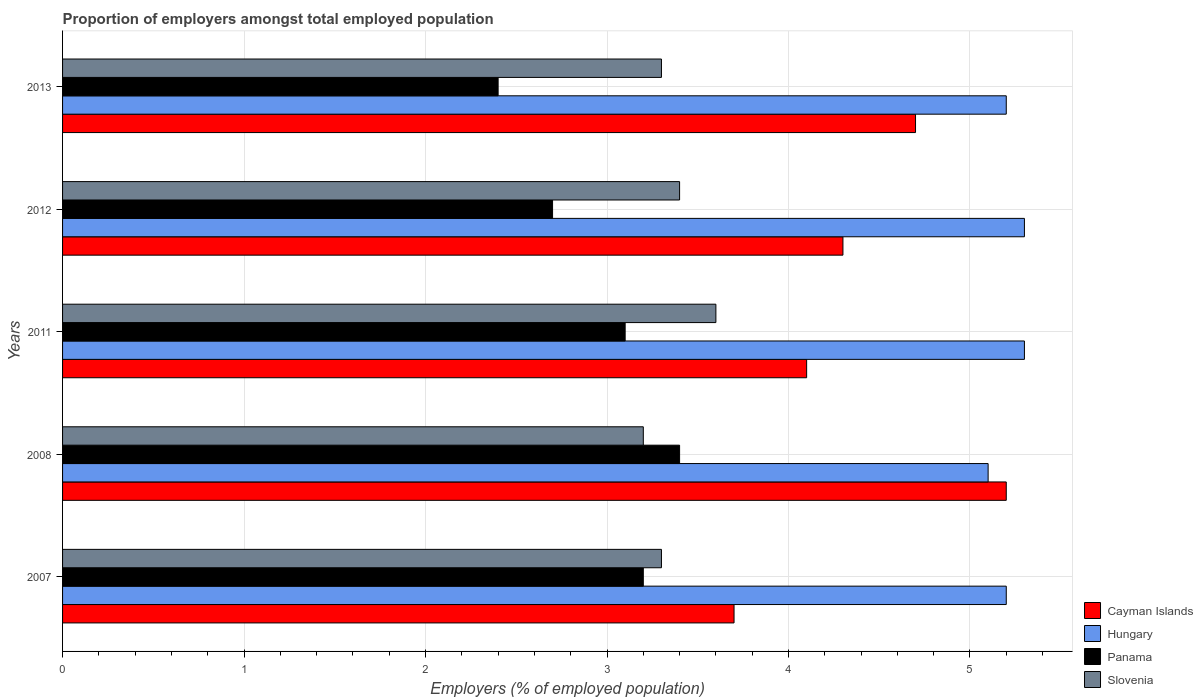How many groups of bars are there?
Your answer should be very brief. 5. Are the number of bars per tick equal to the number of legend labels?
Offer a very short reply. Yes. What is the proportion of employers in Slovenia in 2012?
Keep it short and to the point. 3.4. Across all years, what is the maximum proportion of employers in Cayman Islands?
Offer a terse response. 5.2. Across all years, what is the minimum proportion of employers in Slovenia?
Make the answer very short. 3.2. In which year was the proportion of employers in Hungary maximum?
Your answer should be very brief. 2011. What is the total proportion of employers in Panama in the graph?
Provide a short and direct response. 14.8. What is the difference between the proportion of employers in Hungary in 2008 and that in 2011?
Provide a succinct answer. -0.2. What is the difference between the proportion of employers in Panama in 2007 and the proportion of employers in Slovenia in 2013?
Ensure brevity in your answer.  -0.1. What is the average proportion of employers in Cayman Islands per year?
Provide a succinct answer. 4.4. In the year 2013, what is the difference between the proportion of employers in Slovenia and proportion of employers in Hungary?
Provide a succinct answer. -1.9. What is the ratio of the proportion of employers in Slovenia in 2007 to that in 2013?
Ensure brevity in your answer.  1. What is the difference between the highest and the lowest proportion of employers in Panama?
Keep it short and to the point. 1. What does the 2nd bar from the top in 2013 represents?
Ensure brevity in your answer.  Panama. What does the 3rd bar from the bottom in 2008 represents?
Your answer should be very brief. Panama. Is it the case that in every year, the sum of the proportion of employers in Hungary and proportion of employers in Panama is greater than the proportion of employers in Cayman Islands?
Provide a succinct answer. Yes. What is the difference between two consecutive major ticks on the X-axis?
Provide a short and direct response. 1. Does the graph contain any zero values?
Make the answer very short. No. What is the title of the graph?
Your response must be concise. Proportion of employers amongst total employed population. Does "Djibouti" appear as one of the legend labels in the graph?
Your answer should be compact. No. What is the label or title of the X-axis?
Give a very brief answer. Employers (% of employed population). What is the Employers (% of employed population) in Cayman Islands in 2007?
Give a very brief answer. 3.7. What is the Employers (% of employed population) of Hungary in 2007?
Your answer should be compact. 5.2. What is the Employers (% of employed population) in Panama in 2007?
Give a very brief answer. 3.2. What is the Employers (% of employed population) in Slovenia in 2007?
Your response must be concise. 3.3. What is the Employers (% of employed population) in Cayman Islands in 2008?
Ensure brevity in your answer.  5.2. What is the Employers (% of employed population) of Hungary in 2008?
Your answer should be very brief. 5.1. What is the Employers (% of employed population) of Panama in 2008?
Ensure brevity in your answer.  3.4. What is the Employers (% of employed population) of Slovenia in 2008?
Keep it short and to the point. 3.2. What is the Employers (% of employed population) of Cayman Islands in 2011?
Your response must be concise. 4.1. What is the Employers (% of employed population) in Hungary in 2011?
Offer a very short reply. 5.3. What is the Employers (% of employed population) of Panama in 2011?
Your response must be concise. 3.1. What is the Employers (% of employed population) of Slovenia in 2011?
Provide a short and direct response. 3.6. What is the Employers (% of employed population) in Cayman Islands in 2012?
Give a very brief answer. 4.3. What is the Employers (% of employed population) of Hungary in 2012?
Give a very brief answer. 5.3. What is the Employers (% of employed population) in Panama in 2012?
Keep it short and to the point. 2.7. What is the Employers (% of employed population) in Slovenia in 2012?
Your answer should be compact. 3.4. What is the Employers (% of employed population) of Cayman Islands in 2013?
Your answer should be very brief. 4.7. What is the Employers (% of employed population) of Hungary in 2013?
Ensure brevity in your answer.  5.2. What is the Employers (% of employed population) in Panama in 2013?
Make the answer very short. 2.4. What is the Employers (% of employed population) in Slovenia in 2013?
Provide a short and direct response. 3.3. Across all years, what is the maximum Employers (% of employed population) of Cayman Islands?
Give a very brief answer. 5.2. Across all years, what is the maximum Employers (% of employed population) in Hungary?
Give a very brief answer. 5.3. Across all years, what is the maximum Employers (% of employed population) of Panama?
Provide a succinct answer. 3.4. Across all years, what is the maximum Employers (% of employed population) of Slovenia?
Your answer should be compact. 3.6. Across all years, what is the minimum Employers (% of employed population) in Cayman Islands?
Provide a short and direct response. 3.7. Across all years, what is the minimum Employers (% of employed population) in Hungary?
Your answer should be very brief. 5.1. Across all years, what is the minimum Employers (% of employed population) in Panama?
Give a very brief answer. 2.4. Across all years, what is the minimum Employers (% of employed population) of Slovenia?
Keep it short and to the point. 3.2. What is the total Employers (% of employed population) in Cayman Islands in the graph?
Provide a succinct answer. 22. What is the total Employers (% of employed population) in Hungary in the graph?
Your answer should be very brief. 26.1. What is the total Employers (% of employed population) in Panama in the graph?
Give a very brief answer. 14.8. What is the total Employers (% of employed population) of Slovenia in the graph?
Offer a terse response. 16.8. What is the difference between the Employers (% of employed population) of Cayman Islands in 2007 and that in 2008?
Provide a short and direct response. -1.5. What is the difference between the Employers (% of employed population) of Panama in 2007 and that in 2008?
Your response must be concise. -0.2. What is the difference between the Employers (% of employed population) of Slovenia in 2007 and that in 2008?
Keep it short and to the point. 0.1. What is the difference between the Employers (% of employed population) of Cayman Islands in 2007 and that in 2011?
Your answer should be very brief. -0.4. What is the difference between the Employers (% of employed population) of Hungary in 2007 and that in 2011?
Keep it short and to the point. -0.1. What is the difference between the Employers (% of employed population) of Cayman Islands in 2007 and that in 2012?
Your answer should be very brief. -0.6. What is the difference between the Employers (% of employed population) of Cayman Islands in 2008 and that in 2011?
Offer a terse response. 1.1. What is the difference between the Employers (% of employed population) of Hungary in 2008 and that in 2011?
Your response must be concise. -0.2. What is the difference between the Employers (% of employed population) of Panama in 2008 and that in 2011?
Ensure brevity in your answer.  0.3. What is the difference between the Employers (% of employed population) of Slovenia in 2008 and that in 2011?
Make the answer very short. -0.4. What is the difference between the Employers (% of employed population) in Panama in 2008 and that in 2012?
Offer a very short reply. 0.7. What is the difference between the Employers (% of employed population) in Slovenia in 2008 and that in 2012?
Make the answer very short. -0.2. What is the difference between the Employers (% of employed population) of Cayman Islands in 2011 and that in 2012?
Your answer should be compact. -0.2. What is the difference between the Employers (% of employed population) in Hungary in 2011 and that in 2012?
Ensure brevity in your answer.  0. What is the difference between the Employers (% of employed population) in Panama in 2011 and that in 2012?
Give a very brief answer. 0.4. What is the difference between the Employers (% of employed population) in Cayman Islands in 2011 and that in 2013?
Offer a very short reply. -0.6. What is the difference between the Employers (% of employed population) of Panama in 2011 and that in 2013?
Your response must be concise. 0.7. What is the difference between the Employers (% of employed population) of Slovenia in 2011 and that in 2013?
Make the answer very short. 0.3. What is the difference between the Employers (% of employed population) of Cayman Islands in 2007 and the Employers (% of employed population) of Hungary in 2008?
Provide a succinct answer. -1.4. What is the difference between the Employers (% of employed population) in Cayman Islands in 2007 and the Employers (% of employed population) in Slovenia in 2008?
Your response must be concise. 0.5. What is the difference between the Employers (% of employed population) of Hungary in 2007 and the Employers (% of employed population) of Panama in 2008?
Provide a short and direct response. 1.8. What is the difference between the Employers (% of employed population) in Hungary in 2007 and the Employers (% of employed population) in Slovenia in 2008?
Make the answer very short. 2. What is the difference between the Employers (% of employed population) in Panama in 2007 and the Employers (% of employed population) in Slovenia in 2008?
Your response must be concise. 0. What is the difference between the Employers (% of employed population) of Cayman Islands in 2007 and the Employers (% of employed population) of Hungary in 2011?
Provide a short and direct response. -1.6. What is the difference between the Employers (% of employed population) in Cayman Islands in 2007 and the Employers (% of employed population) in Slovenia in 2011?
Your answer should be compact. 0.1. What is the difference between the Employers (% of employed population) in Hungary in 2007 and the Employers (% of employed population) in Panama in 2011?
Your answer should be compact. 2.1. What is the difference between the Employers (% of employed population) of Hungary in 2007 and the Employers (% of employed population) of Slovenia in 2011?
Keep it short and to the point. 1.6. What is the difference between the Employers (% of employed population) of Hungary in 2007 and the Employers (% of employed population) of Panama in 2012?
Provide a short and direct response. 2.5. What is the difference between the Employers (% of employed population) of Panama in 2007 and the Employers (% of employed population) of Slovenia in 2012?
Your answer should be very brief. -0.2. What is the difference between the Employers (% of employed population) of Hungary in 2007 and the Employers (% of employed population) of Panama in 2013?
Provide a short and direct response. 2.8. What is the difference between the Employers (% of employed population) of Cayman Islands in 2008 and the Employers (% of employed population) of Slovenia in 2011?
Your response must be concise. 1.6. What is the difference between the Employers (% of employed population) in Hungary in 2008 and the Employers (% of employed population) in Panama in 2011?
Your answer should be compact. 2. What is the difference between the Employers (% of employed population) of Hungary in 2008 and the Employers (% of employed population) of Slovenia in 2011?
Your answer should be compact. 1.5. What is the difference between the Employers (% of employed population) in Panama in 2008 and the Employers (% of employed population) in Slovenia in 2011?
Make the answer very short. -0.2. What is the difference between the Employers (% of employed population) in Cayman Islands in 2008 and the Employers (% of employed population) in Hungary in 2012?
Make the answer very short. -0.1. What is the difference between the Employers (% of employed population) in Hungary in 2008 and the Employers (% of employed population) in Panama in 2012?
Offer a terse response. 2.4. What is the difference between the Employers (% of employed population) of Cayman Islands in 2008 and the Employers (% of employed population) of Hungary in 2013?
Keep it short and to the point. 0. What is the difference between the Employers (% of employed population) of Cayman Islands in 2008 and the Employers (% of employed population) of Panama in 2013?
Provide a short and direct response. 2.8. What is the difference between the Employers (% of employed population) in Cayman Islands in 2008 and the Employers (% of employed population) in Slovenia in 2013?
Make the answer very short. 1.9. What is the difference between the Employers (% of employed population) of Hungary in 2008 and the Employers (% of employed population) of Panama in 2013?
Keep it short and to the point. 2.7. What is the difference between the Employers (% of employed population) of Cayman Islands in 2011 and the Employers (% of employed population) of Hungary in 2012?
Keep it short and to the point. -1.2. What is the difference between the Employers (% of employed population) of Cayman Islands in 2011 and the Employers (% of employed population) of Panama in 2012?
Give a very brief answer. 1.4. What is the difference between the Employers (% of employed population) in Hungary in 2011 and the Employers (% of employed population) in Slovenia in 2012?
Offer a terse response. 1.9. What is the difference between the Employers (% of employed population) of Cayman Islands in 2011 and the Employers (% of employed population) of Panama in 2013?
Offer a terse response. 1.7. What is the difference between the Employers (% of employed population) in Cayman Islands in 2011 and the Employers (% of employed population) in Slovenia in 2013?
Ensure brevity in your answer.  0.8. What is the difference between the Employers (% of employed population) in Hungary in 2011 and the Employers (% of employed population) in Slovenia in 2013?
Make the answer very short. 2. What is the difference between the Employers (% of employed population) of Panama in 2011 and the Employers (% of employed population) of Slovenia in 2013?
Your response must be concise. -0.2. What is the difference between the Employers (% of employed population) in Panama in 2012 and the Employers (% of employed population) in Slovenia in 2013?
Give a very brief answer. -0.6. What is the average Employers (% of employed population) of Cayman Islands per year?
Give a very brief answer. 4.4. What is the average Employers (% of employed population) in Hungary per year?
Provide a succinct answer. 5.22. What is the average Employers (% of employed population) in Panama per year?
Your answer should be compact. 2.96. What is the average Employers (% of employed population) in Slovenia per year?
Give a very brief answer. 3.36. In the year 2007, what is the difference between the Employers (% of employed population) in Hungary and Employers (% of employed population) in Slovenia?
Offer a terse response. 1.9. In the year 2008, what is the difference between the Employers (% of employed population) of Cayman Islands and Employers (% of employed population) of Hungary?
Make the answer very short. 0.1. In the year 2008, what is the difference between the Employers (% of employed population) in Cayman Islands and Employers (% of employed population) in Panama?
Ensure brevity in your answer.  1.8. In the year 2008, what is the difference between the Employers (% of employed population) in Cayman Islands and Employers (% of employed population) in Slovenia?
Provide a succinct answer. 2. In the year 2008, what is the difference between the Employers (% of employed population) in Hungary and Employers (% of employed population) in Panama?
Your answer should be very brief. 1.7. In the year 2008, what is the difference between the Employers (% of employed population) in Hungary and Employers (% of employed population) in Slovenia?
Make the answer very short. 1.9. In the year 2011, what is the difference between the Employers (% of employed population) of Cayman Islands and Employers (% of employed population) of Hungary?
Make the answer very short. -1.2. In the year 2011, what is the difference between the Employers (% of employed population) in Cayman Islands and Employers (% of employed population) in Slovenia?
Keep it short and to the point. 0.5. In the year 2012, what is the difference between the Employers (% of employed population) in Hungary and Employers (% of employed population) in Panama?
Your answer should be compact. 2.6. In the year 2012, what is the difference between the Employers (% of employed population) of Hungary and Employers (% of employed population) of Slovenia?
Your answer should be compact. 1.9. In the year 2012, what is the difference between the Employers (% of employed population) of Panama and Employers (% of employed population) of Slovenia?
Ensure brevity in your answer.  -0.7. In the year 2013, what is the difference between the Employers (% of employed population) of Hungary and Employers (% of employed population) of Panama?
Provide a succinct answer. 2.8. In the year 2013, what is the difference between the Employers (% of employed population) in Hungary and Employers (% of employed population) in Slovenia?
Provide a short and direct response. 1.9. In the year 2013, what is the difference between the Employers (% of employed population) in Panama and Employers (% of employed population) in Slovenia?
Offer a terse response. -0.9. What is the ratio of the Employers (% of employed population) of Cayman Islands in 2007 to that in 2008?
Offer a very short reply. 0.71. What is the ratio of the Employers (% of employed population) of Hungary in 2007 to that in 2008?
Offer a terse response. 1.02. What is the ratio of the Employers (% of employed population) of Panama in 2007 to that in 2008?
Keep it short and to the point. 0.94. What is the ratio of the Employers (% of employed population) of Slovenia in 2007 to that in 2008?
Your response must be concise. 1.03. What is the ratio of the Employers (% of employed population) in Cayman Islands in 2007 to that in 2011?
Your answer should be very brief. 0.9. What is the ratio of the Employers (% of employed population) of Hungary in 2007 to that in 2011?
Provide a short and direct response. 0.98. What is the ratio of the Employers (% of employed population) of Panama in 2007 to that in 2011?
Your answer should be very brief. 1.03. What is the ratio of the Employers (% of employed population) of Cayman Islands in 2007 to that in 2012?
Provide a short and direct response. 0.86. What is the ratio of the Employers (% of employed population) in Hungary in 2007 to that in 2012?
Your answer should be very brief. 0.98. What is the ratio of the Employers (% of employed population) of Panama in 2007 to that in 2012?
Ensure brevity in your answer.  1.19. What is the ratio of the Employers (% of employed population) in Slovenia in 2007 to that in 2012?
Offer a very short reply. 0.97. What is the ratio of the Employers (% of employed population) in Cayman Islands in 2007 to that in 2013?
Ensure brevity in your answer.  0.79. What is the ratio of the Employers (% of employed population) in Hungary in 2007 to that in 2013?
Provide a short and direct response. 1. What is the ratio of the Employers (% of employed population) of Cayman Islands in 2008 to that in 2011?
Your answer should be compact. 1.27. What is the ratio of the Employers (% of employed population) of Hungary in 2008 to that in 2011?
Offer a terse response. 0.96. What is the ratio of the Employers (% of employed population) in Panama in 2008 to that in 2011?
Offer a very short reply. 1.1. What is the ratio of the Employers (% of employed population) in Cayman Islands in 2008 to that in 2012?
Provide a short and direct response. 1.21. What is the ratio of the Employers (% of employed population) in Hungary in 2008 to that in 2012?
Provide a short and direct response. 0.96. What is the ratio of the Employers (% of employed population) of Panama in 2008 to that in 2012?
Provide a succinct answer. 1.26. What is the ratio of the Employers (% of employed population) of Slovenia in 2008 to that in 2012?
Make the answer very short. 0.94. What is the ratio of the Employers (% of employed population) of Cayman Islands in 2008 to that in 2013?
Provide a short and direct response. 1.11. What is the ratio of the Employers (% of employed population) of Hungary in 2008 to that in 2013?
Your answer should be compact. 0.98. What is the ratio of the Employers (% of employed population) of Panama in 2008 to that in 2013?
Offer a terse response. 1.42. What is the ratio of the Employers (% of employed population) of Slovenia in 2008 to that in 2013?
Keep it short and to the point. 0.97. What is the ratio of the Employers (% of employed population) of Cayman Islands in 2011 to that in 2012?
Make the answer very short. 0.95. What is the ratio of the Employers (% of employed population) of Panama in 2011 to that in 2012?
Your answer should be very brief. 1.15. What is the ratio of the Employers (% of employed population) in Slovenia in 2011 to that in 2012?
Offer a terse response. 1.06. What is the ratio of the Employers (% of employed population) of Cayman Islands in 2011 to that in 2013?
Provide a succinct answer. 0.87. What is the ratio of the Employers (% of employed population) of Hungary in 2011 to that in 2013?
Offer a terse response. 1.02. What is the ratio of the Employers (% of employed population) of Panama in 2011 to that in 2013?
Your answer should be very brief. 1.29. What is the ratio of the Employers (% of employed population) of Slovenia in 2011 to that in 2013?
Offer a terse response. 1.09. What is the ratio of the Employers (% of employed population) of Cayman Islands in 2012 to that in 2013?
Provide a succinct answer. 0.91. What is the ratio of the Employers (% of employed population) in Hungary in 2012 to that in 2013?
Offer a terse response. 1.02. What is the ratio of the Employers (% of employed population) of Panama in 2012 to that in 2013?
Your answer should be very brief. 1.12. What is the ratio of the Employers (% of employed population) of Slovenia in 2012 to that in 2013?
Offer a terse response. 1.03. What is the difference between the highest and the second highest Employers (% of employed population) in Hungary?
Ensure brevity in your answer.  0. What is the difference between the highest and the second highest Employers (% of employed population) of Panama?
Ensure brevity in your answer.  0.2. What is the difference between the highest and the lowest Employers (% of employed population) in Panama?
Give a very brief answer. 1. 